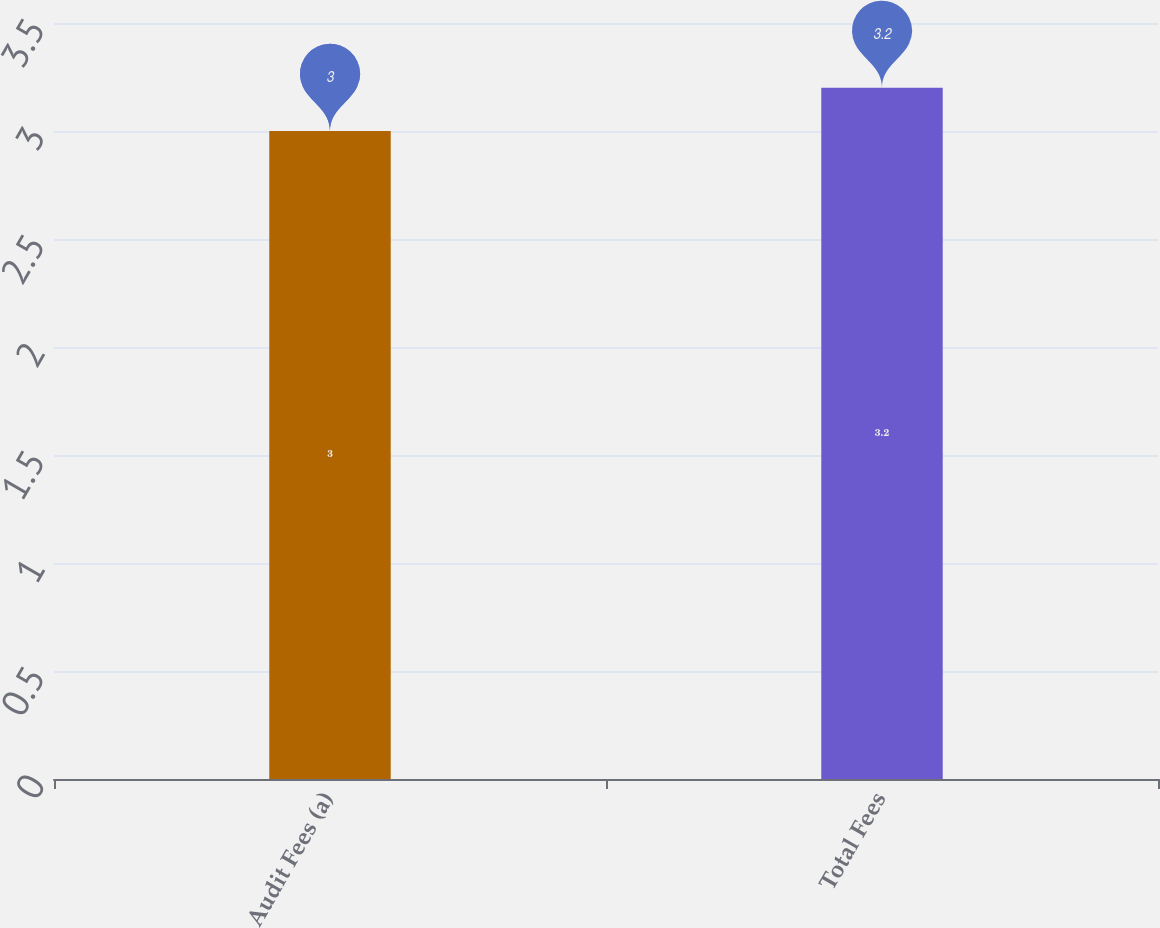Convert chart to OTSL. <chart><loc_0><loc_0><loc_500><loc_500><bar_chart><fcel>Audit Fees (a)<fcel>Total Fees<nl><fcel>3<fcel>3.2<nl></chart> 